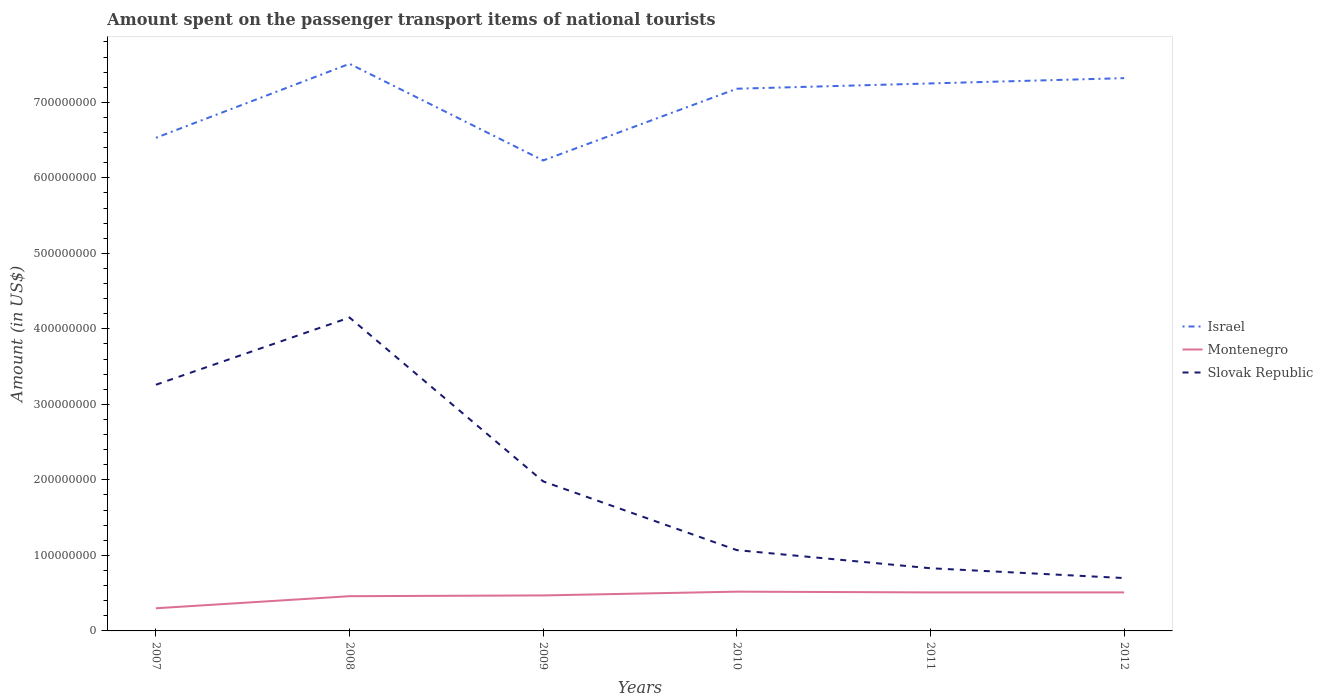Does the line corresponding to Israel intersect with the line corresponding to Slovak Republic?
Your answer should be compact. No. Is the number of lines equal to the number of legend labels?
Offer a terse response. Yes. Across all years, what is the maximum amount spent on the passenger transport items of national tourists in Montenegro?
Offer a terse response. 3.00e+07. What is the total amount spent on the passenger transport items of national tourists in Montenegro in the graph?
Make the answer very short. -1.70e+07. What is the difference between the highest and the second highest amount spent on the passenger transport items of national tourists in Montenegro?
Offer a very short reply. 2.20e+07. Is the amount spent on the passenger transport items of national tourists in Montenegro strictly greater than the amount spent on the passenger transport items of national tourists in Slovak Republic over the years?
Give a very brief answer. Yes. How many years are there in the graph?
Ensure brevity in your answer.  6. Are the values on the major ticks of Y-axis written in scientific E-notation?
Provide a short and direct response. No. Does the graph contain grids?
Keep it short and to the point. No. How many legend labels are there?
Your response must be concise. 3. What is the title of the graph?
Provide a succinct answer. Amount spent on the passenger transport items of national tourists. Does "Djibouti" appear as one of the legend labels in the graph?
Provide a short and direct response. No. What is the label or title of the X-axis?
Provide a short and direct response. Years. What is the Amount (in US$) of Israel in 2007?
Your answer should be very brief. 6.53e+08. What is the Amount (in US$) of Montenegro in 2007?
Offer a terse response. 3.00e+07. What is the Amount (in US$) of Slovak Republic in 2007?
Give a very brief answer. 3.26e+08. What is the Amount (in US$) of Israel in 2008?
Keep it short and to the point. 7.51e+08. What is the Amount (in US$) of Montenegro in 2008?
Give a very brief answer. 4.60e+07. What is the Amount (in US$) of Slovak Republic in 2008?
Keep it short and to the point. 4.15e+08. What is the Amount (in US$) of Israel in 2009?
Give a very brief answer. 6.23e+08. What is the Amount (in US$) in Montenegro in 2009?
Keep it short and to the point. 4.70e+07. What is the Amount (in US$) of Slovak Republic in 2009?
Provide a short and direct response. 1.98e+08. What is the Amount (in US$) in Israel in 2010?
Provide a short and direct response. 7.18e+08. What is the Amount (in US$) of Montenegro in 2010?
Make the answer very short. 5.20e+07. What is the Amount (in US$) of Slovak Republic in 2010?
Give a very brief answer. 1.07e+08. What is the Amount (in US$) of Israel in 2011?
Keep it short and to the point. 7.25e+08. What is the Amount (in US$) of Montenegro in 2011?
Provide a succinct answer. 5.10e+07. What is the Amount (in US$) in Slovak Republic in 2011?
Offer a very short reply. 8.30e+07. What is the Amount (in US$) of Israel in 2012?
Provide a short and direct response. 7.32e+08. What is the Amount (in US$) of Montenegro in 2012?
Provide a succinct answer. 5.10e+07. What is the Amount (in US$) in Slovak Republic in 2012?
Provide a succinct answer. 7.00e+07. Across all years, what is the maximum Amount (in US$) in Israel?
Provide a succinct answer. 7.51e+08. Across all years, what is the maximum Amount (in US$) in Montenegro?
Offer a terse response. 5.20e+07. Across all years, what is the maximum Amount (in US$) in Slovak Republic?
Ensure brevity in your answer.  4.15e+08. Across all years, what is the minimum Amount (in US$) in Israel?
Provide a succinct answer. 6.23e+08. Across all years, what is the minimum Amount (in US$) in Montenegro?
Provide a short and direct response. 3.00e+07. Across all years, what is the minimum Amount (in US$) in Slovak Republic?
Your answer should be compact. 7.00e+07. What is the total Amount (in US$) in Israel in the graph?
Give a very brief answer. 4.20e+09. What is the total Amount (in US$) in Montenegro in the graph?
Ensure brevity in your answer.  2.77e+08. What is the total Amount (in US$) of Slovak Republic in the graph?
Your answer should be very brief. 1.20e+09. What is the difference between the Amount (in US$) in Israel in 2007 and that in 2008?
Offer a terse response. -9.80e+07. What is the difference between the Amount (in US$) of Montenegro in 2007 and that in 2008?
Provide a succinct answer. -1.60e+07. What is the difference between the Amount (in US$) of Slovak Republic in 2007 and that in 2008?
Your answer should be very brief. -8.90e+07. What is the difference between the Amount (in US$) in Israel in 2007 and that in 2009?
Give a very brief answer. 3.00e+07. What is the difference between the Amount (in US$) in Montenegro in 2007 and that in 2009?
Offer a terse response. -1.70e+07. What is the difference between the Amount (in US$) of Slovak Republic in 2007 and that in 2009?
Your answer should be compact. 1.28e+08. What is the difference between the Amount (in US$) in Israel in 2007 and that in 2010?
Make the answer very short. -6.50e+07. What is the difference between the Amount (in US$) of Montenegro in 2007 and that in 2010?
Your answer should be very brief. -2.20e+07. What is the difference between the Amount (in US$) of Slovak Republic in 2007 and that in 2010?
Your answer should be compact. 2.19e+08. What is the difference between the Amount (in US$) of Israel in 2007 and that in 2011?
Give a very brief answer. -7.20e+07. What is the difference between the Amount (in US$) of Montenegro in 2007 and that in 2011?
Make the answer very short. -2.10e+07. What is the difference between the Amount (in US$) in Slovak Republic in 2007 and that in 2011?
Your answer should be very brief. 2.43e+08. What is the difference between the Amount (in US$) of Israel in 2007 and that in 2012?
Offer a very short reply. -7.90e+07. What is the difference between the Amount (in US$) of Montenegro in 2007 and that in 2012?
Your response must be concise. -2.10e+07. What is the difference between the Amount (in US$) in Slovak Republic in 2007 and that in 2012?
Provide a succinct answer. 2.56e+08. What is the difference between the Amount (in US$) of Israel in 2008 and that in 2009?
Your answer should be very brief. 1.28e+08. What is the difference between the Amount (in US$) of Montenegro in 2008 and that in 2009?
Provide a short and direct response. -1.00e+06. What is the difference between the Amount (in US$) in Slovak Republic in 2008 and that in 2009?
Make the answer very short. 2.17e+08. What is the difference between the Amount (in US$) in Israel in 2008 and that in 2010?
Keep it short and to the point. 3.30e+07. What is the difference between the Amount (in US$) in Montenegro in 2008 and that in 2010?
Keep it short and to the point. -6.00e+06. What is the difference between the Amount (in US$) in Slovak Republic in 2008 and that in 2010?
Make the answer very short. 3.08e+08. What is the difference between the Amount (in US$) of Israel in 2008 and that in 2011?
Your answer should be very brief. 2.60e+07. What is the difference between the Amount (in US$) in Montenegro in 2008 and that in 2011?
Your answer should be very brief. -5.00e+06. What is the difference between the Amount (in US$) of Slovak Republic in 2008 and that in 2011?
Your response must be concise. 3.32e+08. What is the difference between the Amount (in US$) of Israel in 2008 and that in 2012?
Keep it short and to the point. 1.90e+07. What is the difference between the Amount (in US$) in Montenegro in 2008 and that in 2012?
Offer a very short reply. -5.00e+06. What is the difference between the Amount (in US$) of Slovak Republic in 2008 and that in 2012?
Make the answer very short. 3.45e+08. What is the difference between the Amount (in US$) of Israel in 2009 and that in 2010?
Provide a succinct answer. -9.50e+07. What is the difference between the Amount (in US$) of Montenegro in 2009 and that in 2010?
Provide a short and direct response. -5.00e+06. What is the difference between the Amount (in US$) of Slovak Republic in 2009 and that in 2010?
Your answer should be very brief. 9.10e+07. What is the difference between the Amount (in US$) of Israel in 2009 and that in 2011?
Provide a succinct answer. -1.02e+08. What is the difference between the Amount (in US$) of Slovak Republic in 2009 and that in 2011?
Provide a short and direct response. 1.15e+08. What is the difference between the Amount (in US$) in Israel in 2009 and that in 2012?
Keep it short and to the point. -1.09e+08. What is the difference between the Amount (in US$) in Slovak Republic in 2009 and that in 2012?
Give a very brief answer. 1.28e+08. What is the difference between the Amount (in US$) in Israel in 2010 and that in 2011?
Provide a succinct answer. -7.00e+06. What is the difference between the Amount (in US$) of Montenegro in 2010 and that in 2011?
Provide a short and direct response. 1.00e+06. What is the difference between the Amount (in US$) of Slovak Republic in 2010 and that in 2011?
Provide a short and direct response. 2.40e+07. What is the difference between the Amount (in US$) of Israel in 2010 and that in 2012?
Offer a terse response. -1.40e+07. What is the difference between the Amount (in US$) in Montenegro in 2010 and that in 2012?
Your answer should be very brief. 1.00e+06. What is the difference between the Amount (in US$) of Slovak Republic in 2010 and that in 2012?
Provide a succinct answer. 3.70e+07. What is the difference between the Amount (in US$) of Israel in 2011 and that in 2012?
Provide a succinct answer. -7.00e+06. What is the difference between the Amount (in US$) in Montenegro in 2011 and that in 2012?
Keep it short and to the point. 0. What is the difference between the Amount (in US$) in Slovak Republic in 2011 and that in 2012?
Give a very brief answer. 1.30e+07. What is the difference between the Amount (in US$) of Israel in 2007 and the Amount (in US$) of Montenegro in 2008?
Your answer should be very brief. 6.07e+08. What is the difference between the Amount (in US$) of Israel in 2007 and the Amount (in US$) of Slovak Republic in 2008?
Offer a terse response. 2.38e+08. What is the difference between the Amount (in US$) of Montenegro in 2007 and the Amount (in US$) of Slovak Republic in 2008?
Offer a very short reply. -3.85e+08. What is the difference between the Amount (in US$) of Israel in 2007 and the Amount (in US$) of Montenegro in 2009?
Ensure brevity in your answer.  6.06e+08. What is the difference between the Amount (in US$) in Israel in 2007 and the Amount (in US$) in Slovak Republic in 2009?
Provide a short and direct response. 4.55e+08. What is the difference between the Amount (in US$) of Montenegro in 2007 and the Amount (in US$) of Slovak Republic in 2009?
Your answer should be very brief. -1.68e+08. What is the difference between the Amount (in US$) in Israel in 2007 and the Amount (in US$) in Montenegro in 2010?
Your answer should be compact. 6.01e+08. What is the difference between the Amount (in US$) in Israel in 2007 and the Amount (in US$) in Slovak Republic in 2010?
Offer a terse response. 5.46e+08. What is the difference between the Amount (in US$) in Montenegro in 2007 and the Amount (in US$) in Slovak Republic in 2010?
Make the answer very short. -7.70e+07. What is the difference between the Amount (in US$) of Israel in 2007 and the Amount (in US$) of Montenegro in 2011?
Ensure brevity in your answer.  6.02e+08. What is the difference between the Amount (in US$) in Israel in 2007 and the Amount (in US$) in Slovak Republic in 2011?
Offer a very short reply. 5.70e+08. What is the difference between the Amount (in US$) in Montenegro in 2007 and the Amount (in US$) in Slovak Republic in 2011?
Provide a succinct answer. -5.30e+07. What is the difference between the Amount (in US$) of Israel in 2007 and the Amount (in US$) of Montenegro in 2012?
Provide a short and direct response. 6.02e+08. What is the difference between the Amount (in US$) of Israel in 2007 and the Amount (in US$) of Slovak Republic in 2012?
Ensure brevity in your answer.  5.83e+08. What is the difference between the Amount (in US$) of Montenegro in 2007 and the Amount (in US$) of Slovak Republic in 2012?
Give a very brief answer. -4.00e+07. What is the difference between the Amount (in US$) in Israel in 2008 and the Amount (in US$) in Montenegro in 2009?
Make the answer very short. 7.04e+08. What is the difference between the Amount (in US$) of Israel in 2008 and the Amount (in US$) of Slovak Republic in 2009?
Keep it short and to the point. 5.53e+08. What is the difference between the Amount (in US$) in Montenegro in 2008 and the Amount (in US$) in Slovak Republic in 2009?
Provide a short and direct response. -1.52e+08. What is the difference between the Amount (in US$) in Israel in 2008 and the Amount (in US$) in Montenegro in 2010?
Provide a short and direct response. 6.99e+08. What is the difference between the Amount (in US$) of Israel in 2008 and the Amount (in US$) of Slovak Republic in 2010?
Make the answer very short. 6.44e+08. What is the difference between the Amount (in US$) of Montenegro in 2008 and the Amount (in US$) of Slovak Republic in 2010?
Your response must be concise. -6.10e+07. What is the difference between the Amount (in US$) in Israel in 2008 and the Amount (in US$) in Montenegro in 2011?
Your answer should be compact. 7.00e+08. What is the difference between the Amount (in US$) in Israel in 2008 and the Amount (in US$) in Slovak Republic in 2011?
Ensure brevity in your answer.  6.68e+08. What is the difference between the Amount (in US$) of Montenegro in 2008 and the Amount (in US$) of Slovak Republic in 2011?
Keep it short and to the point. -3.70e+07. What is the difference between the Amount (in US$) in Israel in 2008 and the Amount (in US$) in Montenegro in 2012?
Offer a terse response. 7.00e+08. What is the difference between the Amount (in US$) of Israel in 2008 and the Amount (in US$) of Slovak Republic in 2012?
Give a very brief answer. 6.81e+08. What is the difference between the Amount (in US$) in Montenegro in 2008 and the Amount (in US$) in Slovak Republic in 2012?
Offer a very short reply. -2.40e+07. What is the difference between the Amount (in US$) of Israel in 2009 and the Amount (in US$) of Montenegro in 2010?
Provide a short and direct response. 5.71e+08. What is the difference between the Amount (in US$) of Israel in 2009 and the Amount (in US$) of Slovak Republic in 2010?
Make the answer very short. 5.16e+08. What is the difference between the Amount (in US$) of Montenegro in 2009 and the Amount (in US$) of Slovak Republic in 2010?
Your answer should be very brief. -6.00e+07. What is the difference between the Amount (in US$) in Israel in 2009 and the Amount (in US$) in Montenegro in 2011?
Provide a short and direct response. 5.72e+08. What is the difference between the Amount (in US$) in Israel in 2009 and the Amount (in US$) in Slovak Republic in 2011?
Your response must be concise. 5.40e+08. What is the difference between the Amount (in US$) in Montenegro in 2009 and the Amount (in US$) in Slovak Republic in 2011?
Ensure brevity in your answer.  -3.60e+07. What is the difference between the Amount (in US$) of Israel in 2009 and the Amount (in US$) of Montenegro in 2012?
Offer a terse response. 5.72e+08. What is the difference between the Amount (in US$) in Israel in 2009 and the Amount (in US$) in Slovak Republic in 2012?
Keep it short and to the point. 5.53e+08. What is the difference between the Amount (in US$) of Montenegro in 2009 and the Amount (in US$) of Slovak Republic in 2012?
Provide a succinct answer. -2.30e+07. What is the difference between the Amount (in US$) in Israel in 2010 and the Amount (in US$) in Montenegro in 2011?
Offer a terse response. 6.67e+08. What is the difference between the Amount (in US$) in Israel in 2010 and the Amount (in US$) in Slovak Republic in 2011?
Your response must be concise. 6.35e+08. What is the difference between the Amount (in US$) of Montenegro in 2010 and the Amount (in US$) of Slovak Republic in 2011?
Provide a short and direct response. -3.10e+07. What is the difference between the Amount (in US$) of Israel in 2010 and the Amount (in US$) of Montenegro in 2012?
Ensure brevity in your answer.  6.67e+08. What is the difference between the Amount (in US$) in Israel in 2010 and the Amount (in US$) in Slovak Republic in 2012?
Keep it short and to the point. 6.48e+08. What is the difference between the Amount (in US$) in Montenegro in 2010 and the Amount (in US$) in Slovak Republic in 2012?
Give a very brief answer. -1.80e+07. What is the difference between the Amount (in US$) in Israel in 2011 and the Amount (in US$) in Montenegro in 2012?
Provide a short and direct response. 6.74e+08. What is the difference between the Amount (in US$) in Israel in 2011 and the Amount (in US$) in Slovak Republic in 2012?
Offer a very short reply. 6.55e+08. What is the difference between the Amount (in US$) in Montenegro in 2011 and the Amount (in US$) in Slovak Republic in 2012?
Your answer should be very brief. -1.90e+07. What is the average Amount (in US$) of Israel per year?
Make the answer very short. 7.00e+08. What is the average Amount (in US$) of Montenegro per year?
Ensure brevity in your answer.  4.62e+07. What is the average Amount (in US$) in Slovak Republic per year?
Make the answer very short. 2.00e+08. In the year 2007, what is the difference between the Amount (in US$) in Israel and Amount (in US$) in Montenegro?
Your answer should be compact. 6.23e+08. In the year 2007, what is the difference between the Amount (in US$) of Israel and Amount (in US$) of Slovak Republic?
Your response must be concise. 3.27e+08. In the year 2007, what is the difference between the Amount (in US$) in Montenegro and Amount (in US$) in Slovak Republic?
Offer a terse response. -2.96e+08. In the year 2008, what is the difference between the Amount (in US$) of Israel and Amount (in US$) of Montenegro?
Your response must be concise. 7.05e+08. In the year 2008, what is the difference between the Amount (in US$) in Israel and Amount (in US$) in Slovak Republic?
Your answer should be very brief. 3.36e+08. In the year 2008, what is the difference between the Amount (in US$) of Montenegro and Amount (in US$) of Slovak Republic?
Offer a very short reply. -3.69e+08. In the year 2009, what is the difference between the Amount (in US$) in Israel and Amount (in US$) in Montenegro?
Ensure brevity in your answer.  5.76e+08. In the year 2009, what is the difference between the Amount (in US$) of Israel and Amount (in US$) of Slovak Republic?
Offer a terse response. 4.25e+08. In the year 2009, what is the difference between the Amount (in US$) of Montenegro and Amount (in US$) of Slovak Republic?
Ensure brevity in your answer.  -1.51e+08. In the year 2010, what is the difference between the Amount (in US$) in Israel and Amount (in US$) in Montenegro?
Offer a very short reply. 6.66e+08. In the year 2010, what is the difference between the Amount (in US$) of Israel and Amount (in US$) of Slovak Republic?
Your response must be concise. 6.11e+08. In the year 2010, what is the difference between the Amount (in US$) of Montenegro and Amount (in US$) of Slovak Republic?
Your answer should be very brief. -5.50e+07. In the year 2011, what is the difference between the Amount (in US$) of Israel and Amount (in US$) of Montenegro?
Your answer should be compact. 6.74e+08. In the year 2011, what is the difference between the Amount (in US$) of Israel and Amount (in US$) of Slovak Republic?
Offer a terse response. 6.42e+08. In the year 2011, what is the difference between the Amount (in US$) in Montenegro and Amount (in US$) in Slovak Republic?
Offer a very short reply. -3.20e+07. In the year 2012, what is the difference between the Amount (in US$) of Israel and Amount (in US$) of Montenegro?
Ensure brevity in your answer.  6.81e+08. In the year 2012, what is the difference between the Amount (in US$) of Israel and Amount (in US$) of Slovak Republic?
Keep it short and to the point. 6.62e+08. In the year 2012, what is the difference between the Amount (in US$) in Montenegro and Amount (in US$) in Slovak Republic?
Provide a short and direct response. -1.90e+07. What is the ratio of the Amount (in US$) of Israel in 2007 to that in 2008?
Ensure brevity in your answer.  0.87. What is the ratio of the Amount (in US$) of Montenegro in 2007 to that in 2008?
Give a very brief answer. 0.65. What is the ratio of the Amount (in US$) in Slovak Republic in 2007 to that in 2008?
Your response must be concise. 0.79. What is the ratio of the Amount (in US$) of Israel in 2007 to that in 2009?
Provide a short and direct response. 1.05. What is the ratio of the Amount (in US$) of Montenegro in 2007 to that in 2009?
Give a very brief answer. 0.64. What is the ratio of the Amount (in US$) of Slovak Republic in 2007 to that in 2009?
Offer a very short reply. 1.65. What is the ratio of the Amount (in US$) of Israel in 2007 to that in 2010?
Your answer should be compact. 0.91. What is the ratio of the Amount (in US$) in Montenegro in 2007 to that in 2010?
Your response must be concise. 0.58. What is the ratio of the Amount (in US$) in Slovak Republic in 2007 to that in 2010?
Offer a terse response. 3.05. What is the ratio of the Amount (in US$) in Israel in 2007 to that in 2011?
Your answer should be compact. 0.9. What is the ratio of the Amount (in US$) of Montenegro in 2007 to that in 2011?
Your answer should be very brief. 0.59. What is the ratio of the Amount (in US$) of Slovak Republic in 2007 to that in 2011?
Offer a terse response. 3.93. What is the ratio of the Amount (in US$) of Israel in 2007 to that in 2012?
Your answer should be very brief. 0.89. What is the ratio of the Amount (in US$) of Montenegro in 2007 to that in 2012?
Ensure brevity in your answer.  0.59. What is the ratio of the Amount (in US$) of Slovak Republic in 2007 to that in 2012?
Ensure brevity in your answer.  4.66. What is the ratio of the Amount (in US$) in Israel in 2008 to that in 2009?
Your response must be concise. 1.21. What is the ratio of the Amount (in US$) of Montenegro in 2008 to that in 2009?
Your response must be concise. 0.98. What is the ratio of the Amount (in US$) in Slovak Republic in 2008 to that in 2009?
Give a very brief answer. 2.1. What is the ratio of the Amount (in US$) of Israel in 2008 to that in 2010?
Your response must be concise. 1.05. What is the ratio of the Amount (in US$) of Montenegro in 2008 to that in 2010?
Your answer should be very brief. 0.88. What is the ratio of the Amount (in US$) in Slovak Republic in 2008 to that in 2010?
Provide a short and direct response. 3.88. What is the ratio of the Amount (in US$) in Israel in 2008 to that in 2011?
Offer a very short reply. 1.04. What is the ratio of the Amount (in US$) of Montenegro in 2008 to that in 2011?
Give a very brief answer. 0.9. What is the ratio of the Amount (in US$) in Slovak Republic in 2008 to that in 2011?
Offer a very short reply. 5. What is the ratio of the Amount (in US$) of Montenegro in 2008 to that in 2012?
Your answer should be compact. 0.9. What is the ratio of the Amount (in US$) in Slovak Republic in 2008 to that in 2012?
Offer a very short reply. 5.93. What is the ratio of the Amount (in US$) of Israel in 2009 to that in 2010?
Your response must be concise. 0.87. What is the ratio of the Amount (in US$) of Montenegro in 2009 to that in 2010?
Give a very brief answer. 0.9. What is the ratio of the Amount (in US$) of Slovak Republic in 2009 to that in 2010?
Your answer should be very brief. 1.85. What is the ratio of the Amount (in US$) in Israel in 2009 to that in 2011?
Give a very brief answer. 0.86. What is the ratio of the Amount (in US$) of Montenegro in 2009 to that in 2011?
Offer a terse response. 0.92. What is the ratio of the Amount (in US$) in Slovak Republic in 2009 to that in 2011?
Offer a very short reply. 2.39. What is the ratio of the Amount (in US$) of Israel in 2009 to that in 2012?
Offer a terse response. 0.85. What is the ratio of the Amount (in US$) of Montenegro in 2009 to that in 2012?
Provide a succinct answer. 0.92. What is the ratio of the Amount (in US$) of Slovak Republic in 2009 to that in 2012?
Provide a succinct answer. 2.83. What is the ratio of the Amount (in US$) in Israel in 2010 to that in 2011?
Provide a short and direct response. 0.99. What is the ratio of the Amount (in US$) of Montenegro in 2010 to that in 2011?
Your answer should be very brief. 1.02. What is the ratio of the Amount (in US$) in Slovak Republic in 2010 to that in 2011?
Make the answer very short. 1.29. What is the ratio of the Amount (in US$) in Israel in 2010 to that in 2012?
Provide a succinct answer. 0.98. What is the ratio of the Amount (in US$) of Montenegro in 2010 to that in 2012?
Give a very brief answer. 1.02. What is the ratio of the Amount (in US$) in Slovak Republic in 2010 to that in 2012?
Make the answer very short. 1.53. What is the ratio of the Amount (in US$) of Israel in 2011 to that in 2012?
Make the answer very short. 0.99. What is the ratio of the Amount (in US$) in Montenegro in 2011 to that in 2012?
Offer a terse response. 1. What is the ratio of the Amount (in US$) of Slovak Republic in 2011 to that in 2012?
Provide a succinct answer. 1.19. What is the difference between the highest and the second highest Amount (in US$) in Israel?
Your answer should be very brief. 1.90e+07. What is the difference between the highest and the second highest Amount (in US$) in Slovak Republic?
Provide a succinct answer. 8.90e+07. What is the difference between the highest and the lowest Amount (in US$) in Israel?
Make the answer very short. 1.28e+08. What is the difference between the highest and the lowest Amount (in US$) of Montenegro?
Give a very brief answer. 2.20e+07. What is the difference between the highest and the lowest Amount (in US$) in Slovak Republic?
Keep it short and to the point. 3.45e+08. 